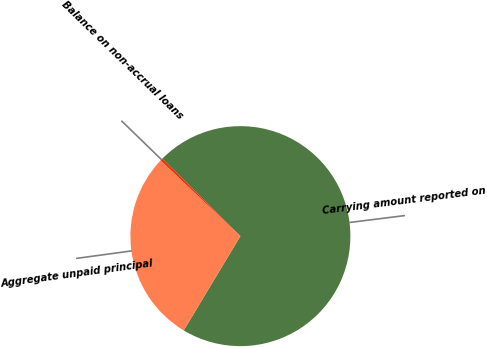Convert chart to OTSL. <chart><loc_0><loc_0><loc_500><loc_500><pie_chart><fcel>Carrying amount reported on<fcel>Aggregate unpaid principal<fcel>Balance on non-accrual loans<nl><fcel>71.19%<fcel>28.47%<fcel>0.34%<nl></chart> 